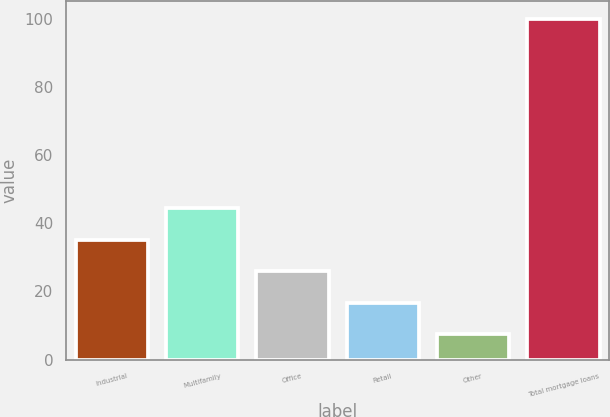Convert chart to OTSL. <chart><loc_0><loc_0><loc_500><loc_500><bar_chart><fcel>Industrial<fcel>Multifamily<fcel>Office<fcel>Retail<fcel>Other<fcel>Total mortgage loans<nl><fcel>35.18<fcel>44.44<fcel>25.92<fcel>16.66<fcel>7.4<fcel>100<nl></chart> 